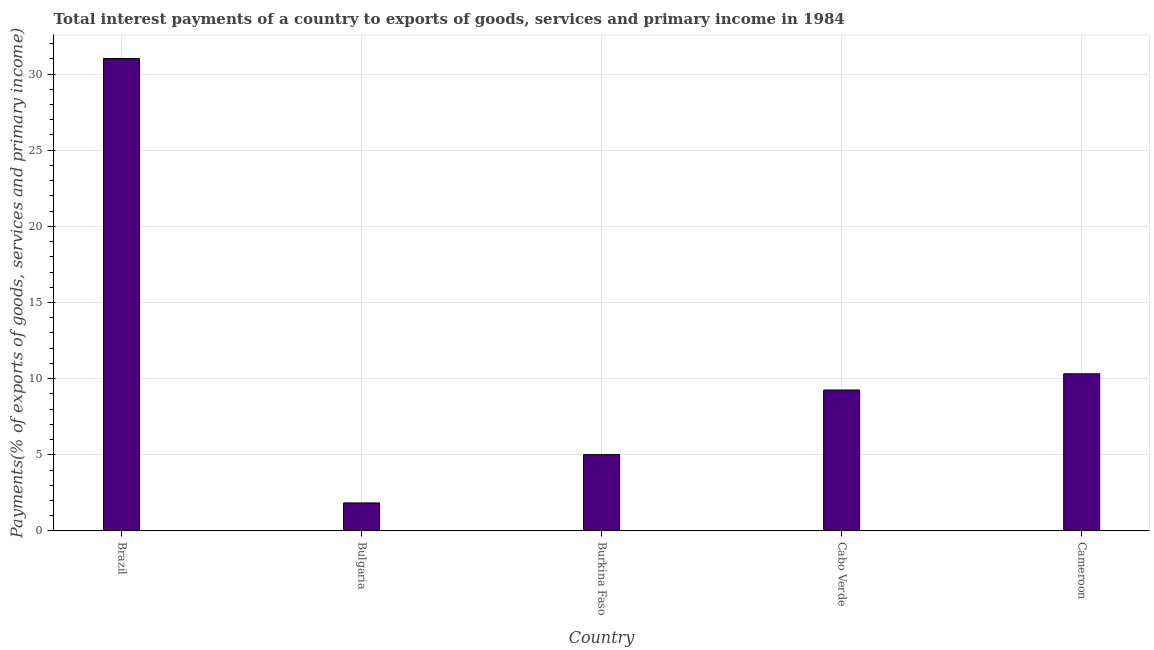What is the title of the graph?
Your answer should be compact. Total interest payments of a country to exports of goods, services and primary income in 1984. What is the label or title of the Y-axis?
Provide a short and direct response. Payments(% of exports of goods, services and primary income). What is the total interest payments on external debt in Bulgaria?
Offer a very short reply. 1.84. Across all countries, what is the maximum total interest payments on external debt?
Keep it short and to the point. 31.02. Across all countries, what is the minimum total interest payments on external debt?
Keep it short and to the point. 1.84. In which country was the total interest payments on external debt maximum?
Provide a succinct answer. Brazil. What is the sum of the total interest payments on external debt?
Offer a terse response. 57.45. What is the difference between the total interest payments on external debt in Burkina Faso and Cabo Verde?
Keep it short and to the point. -4.24. What is the average total interest payments on external debt per country?
Your response must be concise. 11.49. What is the median total interest payments on external debt?
Offer a terse response. 9.26. In how many countries, is the total interest payments on external debt greater than 4 %?
Offer a very short reply. 4. What is the ratio of the total interest payments on external debt in Bulgaria to that in Burkina Faso?
Make the answer very short. 0.37. Is the difference between the total interest payments on external debt in Bulgaria and Cameroon greater than the difference between any two countries?
Offer a very short reply. No. What is the difference between the highest and the second highest total interest payments on external debt?
Make the answer very short. 20.7. What is the difference between the highest and the lowest total interest payments on external debt?
Your response must be concise. 29.18. In how many countries, is the total interest payments on external debt greater than the average total interest payments on external debt taken over all countries?
Provide a succinct answer. 1. Are all the bars in the graph horizontal?
Provide a short and direct response. No. How many countries are there in the graph?
Offer a terse response. 5. What is the Payments(% of exports of goods, services and primary income) in Brazil?
Keep it short and to the point. 31.02. What is the Payments(% of exports of goods, services and primary income) in Bulgaria?
Make the answer very short. 1.84. What is the Payments(% of exports of goods, services and primary income) of Burkina Faso?
Make the answer very short. 5.01. What is the Payments(% of exports of goods, services and primary income) in Cabo Verde?
Ensure brevity in your answer.  9.26. What is the Payments(% of exports of goods, services and primary income) of Cameroon?
Provide a short and direct response. 10.32. What is the difference between the Payments(% of exports of goods, services and primary income) in Brazil and Bulgaria?
Ensure brevity in your answer.  29.18. What is the difference between the Payments(% of exports of goods, services and primary income) in Brazil and Burkina Faso?
Make the answer very short. 26.01. What is the difference between the Payments(% of exports of goods, services and primary income) in Brazil and Cabo Verde?
Your response must be concise. 21.77. What is the difference between the Payments(% of exports of goods, services and primary income) in Brazil and Cameroon?
Offer a terse response. 20.7. What is the difference between the Payments(% of exports of goods, services and primary income) in Bulgaria and Burkina Faso?
Your response must be concise. -3.17. What is the difference between the Payments(% of exports of goods, services and primary income) in Bulgaria and Cabo Verde?
Provide a succinct answer. -7.42. What is the difference between the Payments(% of exports of goods, services and primary income) in Bulgaria and Cameroon?
Offer a very short reply. -8.48. What is the difference between the Payments(% of exports of goods, services and primary income) in Burkina Faso and Cabo Verde?
Keep it short and to the point. -4.24. What is the difference between the Payments(% of exports of goods, services and primary income) in Burkina Faso and Cameroon?
Offer a terse response. -5.31. What is the difference between the Payments(% of exports of goods, services and primary income) in Cabo Verde and Cameroon?
Your answer should be compact. -1.06. What is the ratio of the Payments(% of exports of goods, services and primary income) in Brazil to that in Bulgaria?
Keep it short and to the point. 16.87. What is the ratio of the Payments(% of exports of goods, services and primary income) in Brazil to that in Burkina Faso?
Make the answer very short. 6.19. What is the ratio of the Payments(% of exports of goods, services and primary income) in Brazil to that in Cabo Verde?
Provide a short and direct response. 3.35. What is the ratio of the Payments(% of exports of goods, services and primary income) in Brazil to that in Cameroon?
Ensure brevity in your answer.  3.01. What is the ratio of the Payments(% of exports of goods, services and primary income) in Bulgaria to that in Burkina Faso?
Provide a short and direct response. 0.37. What is the ratio of the Payments(% of exports of goods, services and primary income) in Bulgaria to that in Cabo Verde?
Your answer should be very brief. 0.2. What is the ratio of the Payments(% of exports of goods, services and primary income) in Bulgaria to that in Cameroon?
Offer a very short reply. 0.18. What is the ratio of the Payments(% of exports of goods, services and primary income) in Burkina Faso to that in Cabo Verde?
Give a very brief answer. 0.54. What is the ratio of the Payments(% of exports of goods, services and primary income) in Burkina Faso to that in Cameroon?
Offer a very short reply. 0.49. What is the ratio of the Payments(% of exports of goods, services and primary income) in Cabo Verde to that in Cameroon?
Provide a succinct answer. 0.9. 